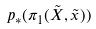Convert formula to latex. <formula><loc_0><loc_0><loc_500><loc_500>p _ { * } ( \pi _ { 1 } ( \tilde { X } , \tilde { x } ) )</formula> 